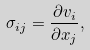<formula> <loc_0><loc_0><loc_500><loc_500>\sigma _ { i j } = \frac { \partial v _ { i } } { \partial x _ { j } } ,</formula> 